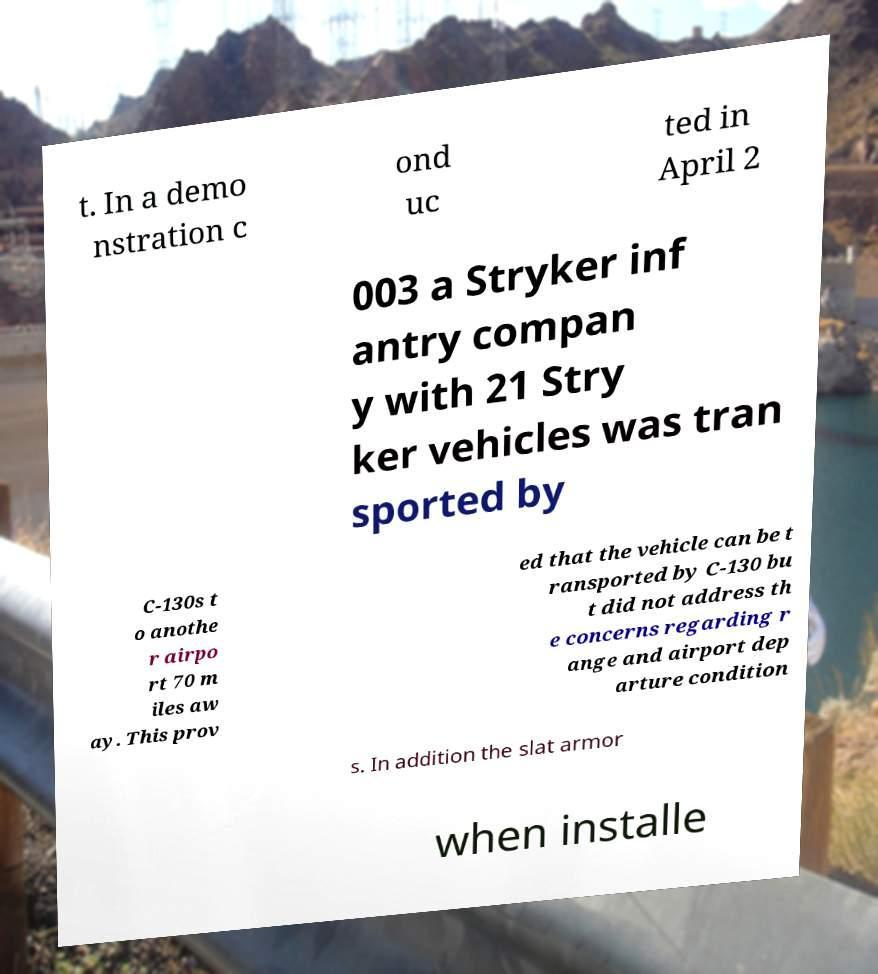For documentation purposes, I need the text within this image transcribed. Could you provide that? t. In a demo nstration c ond uc ted in April 2 003 a Stryker inf antry compan y with 21 Stry ker vehicles was tran sported by C-130s t o anothe r airpo rt 70 m iles aw ay. This prov ed that the vehicle can be t ransported by C-130 bu t did not address th e concerns regarding r ange and airport dep arture condition s. In addition the slat armor when installe 